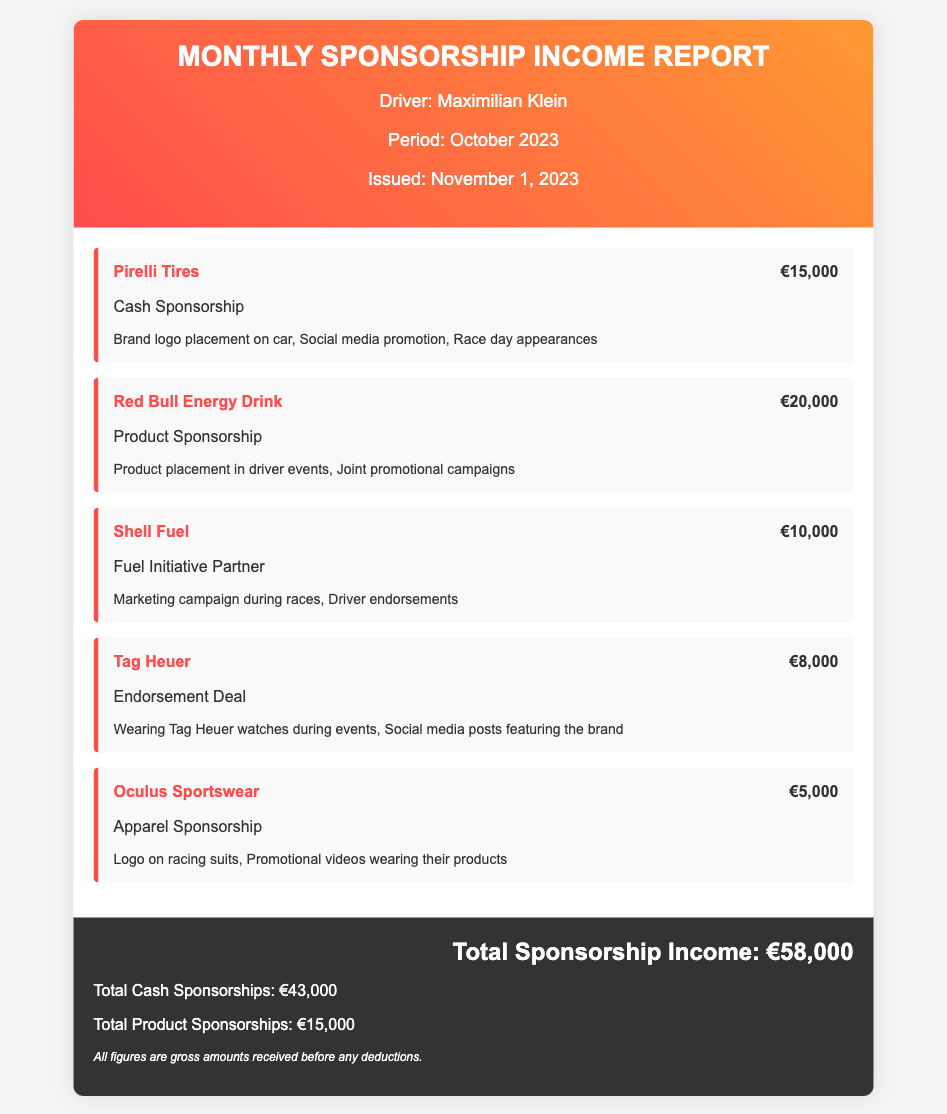What is the driver's name? The driver's name is mentioned at the top of the document, indicating who the report is for.
Answer: Maximilian Klein What is the total amount of sponsorship income? The total sponsorship income is summarized at the bottom of the report as a key figure.
Answer: €58,000 Which sponsor provided €20,000? The specific sponsor and the amount is stated clearly in the item listing within the document.
Answer: Red Bull Energy Drink How much did Tag Heuer contribute? The contribution amount for Tag Heuer is found in the details of sponsorships.
Answer: €8,000 What is the total amount for cash sponsorships? Cash sponsorships are specifically summarized in the financial totals section of the report.
Answer: €43,000 What type of sponsorship is Oculus Sportswear classified as? The classification of Oculus Sportswear is mentioned among the sponsorship details.
Answer: Apparel Sponsorship What promotional activities are indicated for Pirelli Tires? The document lists specific activities associated with each sponsor, including Pirelli Tires.
Answer: Brand logo placement on car, Social media promotion, Race day appearances How many unique sponsors are listed in the report? The number of sponsors can be counted directly from the document's itemized list.
Answer: 5 What is the date when the report was issued? The report explicitly states the date of issue within the driver's information section.
Answer: November 1, 2023 